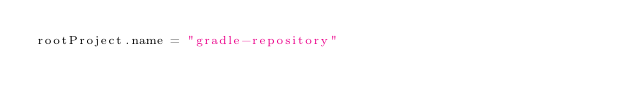<code> <loc_0><loc_0><loc_500><loc_500><_Kotlin_>rootProject.name = "gradle-repository"
</code> 